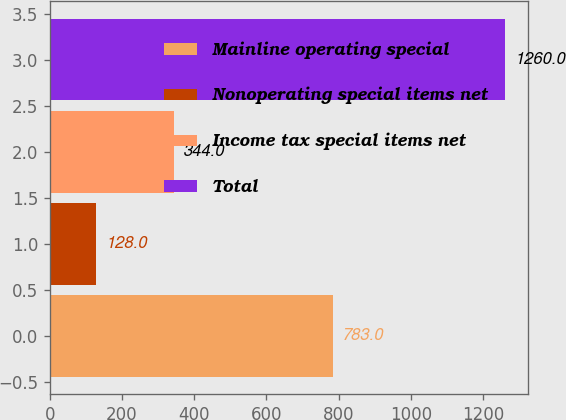Convert chart to OTSL. <chart><loc_0><loc_0><loc_500><loc_500><bar_chart><fcel>Mainline operating special<fcel>Nonoperating special items net<fcel>Income tax special items net<fcel>Total<nl><fcel>783<fcel>128<fcel>344<fcel>1260<nl></chart> 